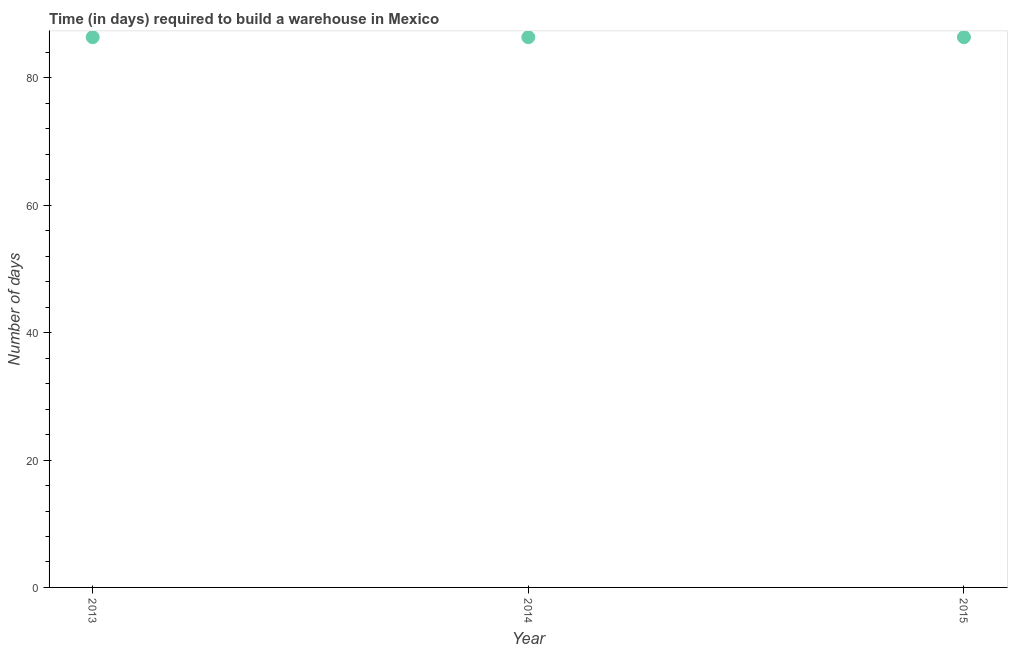What is the time required to build a warehouse in 2013?
Make the answer very short. 86.4. Across all years, what is the maximum time required to build a warehouse?
Your response must be concise. 86.4. Across all years, what is the minimum time required to build a warehouse?
Your answer should be compact. 86.4. In which year was the time required to build a warehouse maximum?
Keep it short and to the point. 2013. In which year was the time required to build a warehouse minimum?
Provide a succinct answer. 2013. What is the sum of the time required to build a warehouse?
Ensure brevity in your answer.  259.2. What is the average time required to build a warehouse per year?
Provide a succinct answer. 86.4. What is the median time required to build a warehouse?
Offer a terse response. 86.4. Do a majority of the years between 2015 and 2013 (inclusive) have time required to build a warehouse greater than 72 days?
Provide a succinct answer. No. What is the ratio of the time required to build a warehouse in 2013 to that in 2015?
Your response must be concise. 1. Is the time required to build a warehouse in 2013 less than that in 2015?
Provide a short and direct response. No. Is the difference between the time required to build a warehouse in 2013 and 2014 greater than the difference between any two years?
Give a very brief answer. Yes. Is the sum of the time required to build a warehouse in 2013 and 2014 greater than the maximum time required to build a warehouse across all years?
Provide a short and direct response. Yes. In how many years, is the time required to build a warehouse greater than the average time required to build a warehouse taken over all years?
Your response must be concise. 0. Does the time required to build a warehouse monotonically increase over the years?
Offer a terse response. No. What is the title of the graph?
Keep it short and to the point. Time (in days) required to build a warehouse in Mexico. What is the label or title of the Y-axis?
Your answer should be very brief. Number of days. What is the Number of days in 2013?
Make the answer very short. 86.4. What is the Number of days in 2014?
Make the answer very short. 86.4. What is the Number of days in 2015?
Your response must be concise. 86.4. What is the ratio of the Number of days in 2013 to that in 2015?
Your answer should be very brief. 1. What is the ratio of the Number of days in 2014 to that in 2015?
Keep it short and to the point. 1. 